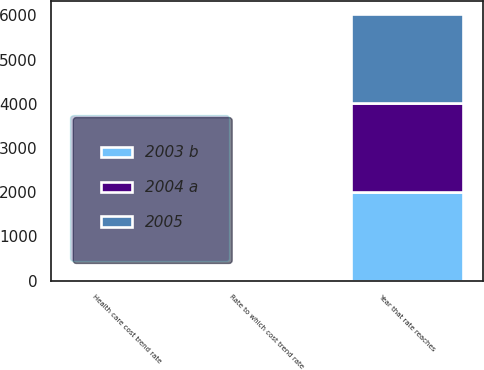Convert chart. <chart><loc_0><loc_0><loc_500><loc_500><stacked_bar_chart><ecel><fcel>Health care cost trend rate<fcel>Rate to which cost trend rate<fcel>Year that rate reaches<nl><fcel>2004 a<fcel>10<fcel>5<fcel>2012<nl><fcel>2003 b<fcel>10<fcel>5<fcel>2011<nl><fcel>2005<fcel>10<fcel>5<fcel>2010<nl></chart> 